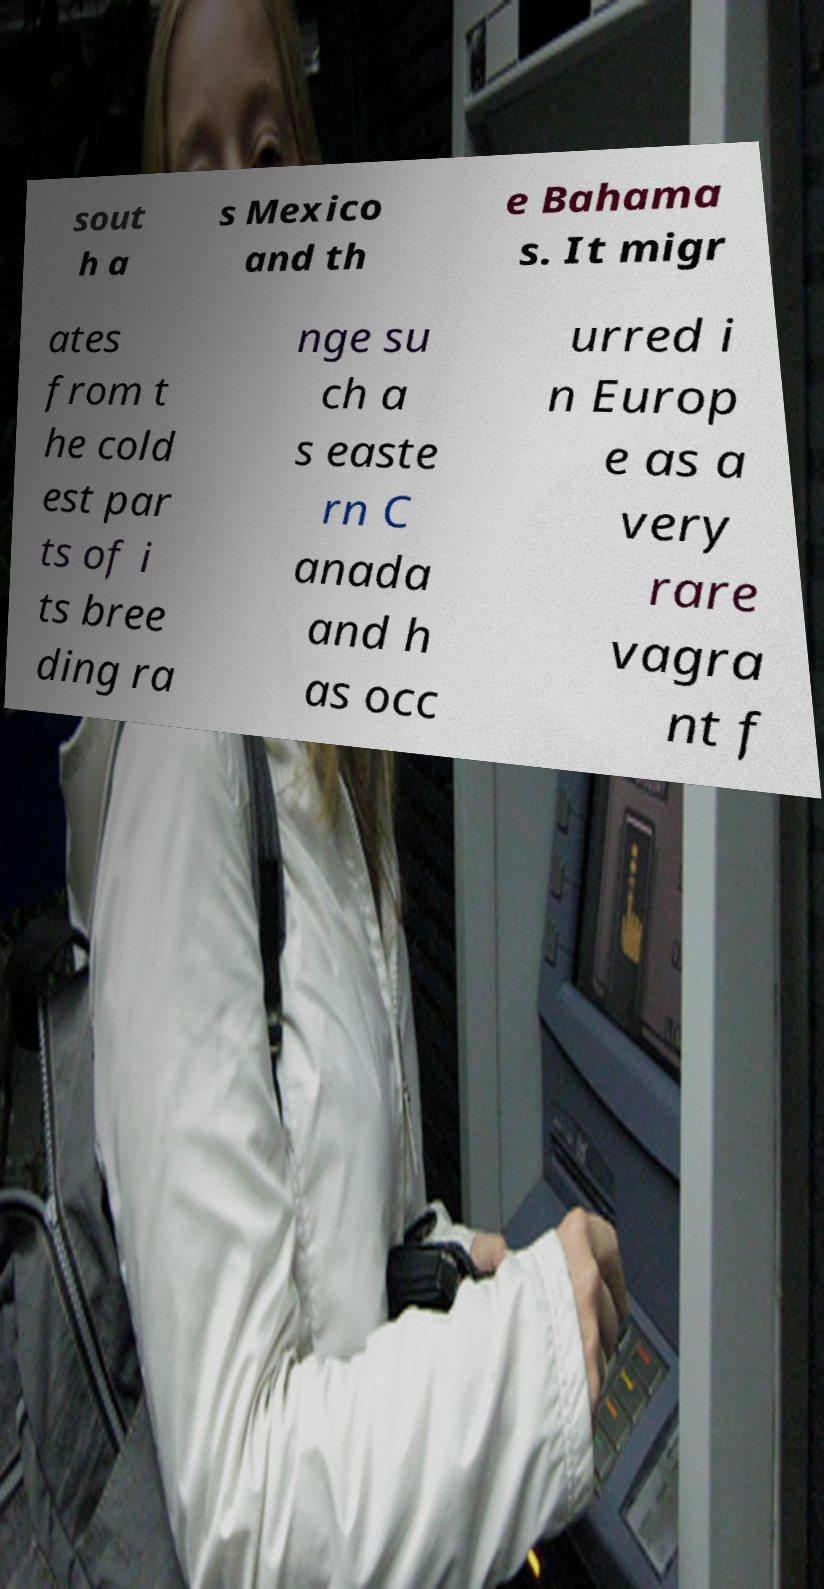Could you extract and type out the text from this image? sout h a s Mexico and th e Bahama s. It migr ates from t he cold est par ts of i ts bree ding ra nge su ch a s easte rn C anada and h as occ urred i n Europ e as a very rare vagra nt f 